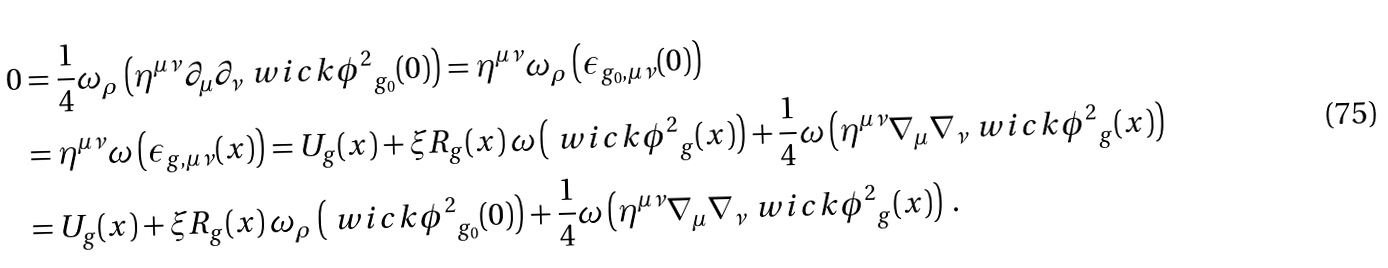<formula> <loc_0><loc_0><loc_500><loc_500>0 & = \frac { 1 } { 4 } \omega _ { \rho } \left ( \eta ^ { \mu \nu } \partial _ { \mu } \partial _ { \nu } \ w i c k { \phi ^ { 2 } } _ { g _ { 0 } } ( 0 ) \right ) = \eta ^ { \mu \nu } \omega _ { \rho } \left ( \epsilon _ { g _ { 0 } , \mu \nu } ( 0 ) \right ) \\ & = \eta ^ { \mu \nu } \omega \left ( \epsilon _ { g , \mu \nu } ( x ) \right ) = U _ { g } ( x ) + \xi R _ { g } ( x ) \, \omega \left ( \ w i c k { \phi ^ { 2 } } _ { g } ( x ) \right ) + \frac { 1 } { 4 } \omega \left ( \eta ^ { \mu \nu } \nabla _ { \mu } \nabla _ { \nu } \ w i c k { \phi ^ { 2 } } _ { g } ( x ) \right ) \\ & = U _ { g } ( x ) + \xi R _ { g } ( x ) \, \omega _ { \rho } \left ( \ w i c k { \phi ^ { 2 } } _ { g _ { 0 } } ( 0 ) \right ) + \frac { 1 } { 4 } \omega \left ( \eta ^ { \mu \nu } \nabla _ { \mu } \nabla _ { \nu } \ w i c k { \phi ^ { 2 } } _ { g } ( x ) \right ) \, .</formula> 